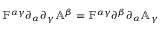<formula> <loc_0><loc_0><loc_500><loc_500>\mathbb { F } ^ { \alpha \gamma } \partial _ { \alpha } \partial _ { \gamma } \mathbb { A } ^ { \beta } = \mathbb { F } ^ { \alpha \gamma } \partial ^ { \beta } \partial _ { \alpha } \mathbb { A } _ { \gamma }</formula> 